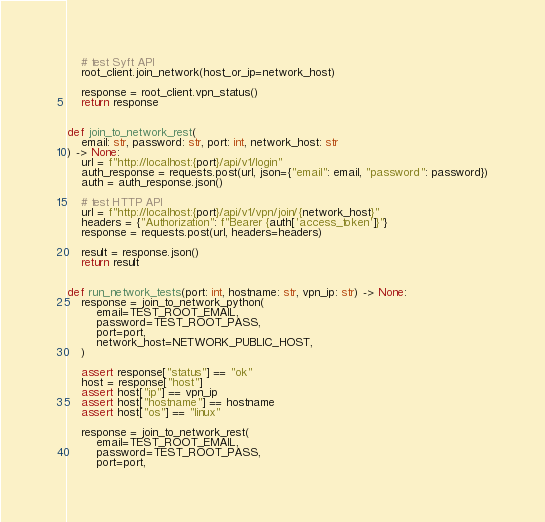Convert code to text. <code><loc_0><loc_0><loc_500><loc_500><_Python_>    # test Syft API
    root_client.join_network(host_or_ip=network_host)

    response = root_client.vpn_status()
    return response


def join_to_network_rest(
    email: str, password: str, port: int, network_host: str
) -> None:
    url = f"http://localhost:{port}/api/v1/login"
    auth_response = requests.post(url, json={"email": email, "password": password})
    auth = auth_response.json()

    # test HTTP API
    url = f"http://localhost:{port}/api/v1/vpn/join/{network_host}"
    headers = {"Authorization": f"Bearer {auth['access_token']}"}
    response = requests.post(url, headers=headers)

    result = response.json()
    return result


def run_network_tests(port: int, hostname: str, vpn_ip: str) -> None:
    response = join_to_network_python(
        email=TEST_ROOT_EMAIL,
        password=TEST_ROOT_PASS,
        port=port,
        network_host=NETWORK_PUBLIC_HOST,
    )

    assert response["status"] == "ok"
    host = response["host"]
    assert host["ip"] == vpn_ip
    assert host["hostname"] == hostname
    assert host["os"] == "linux"

    response = join_to_network_rest(
        email=TEST_ROOT_EMAIL,
        password=TEST_ROOT_PASS,
        port=port,</code> 